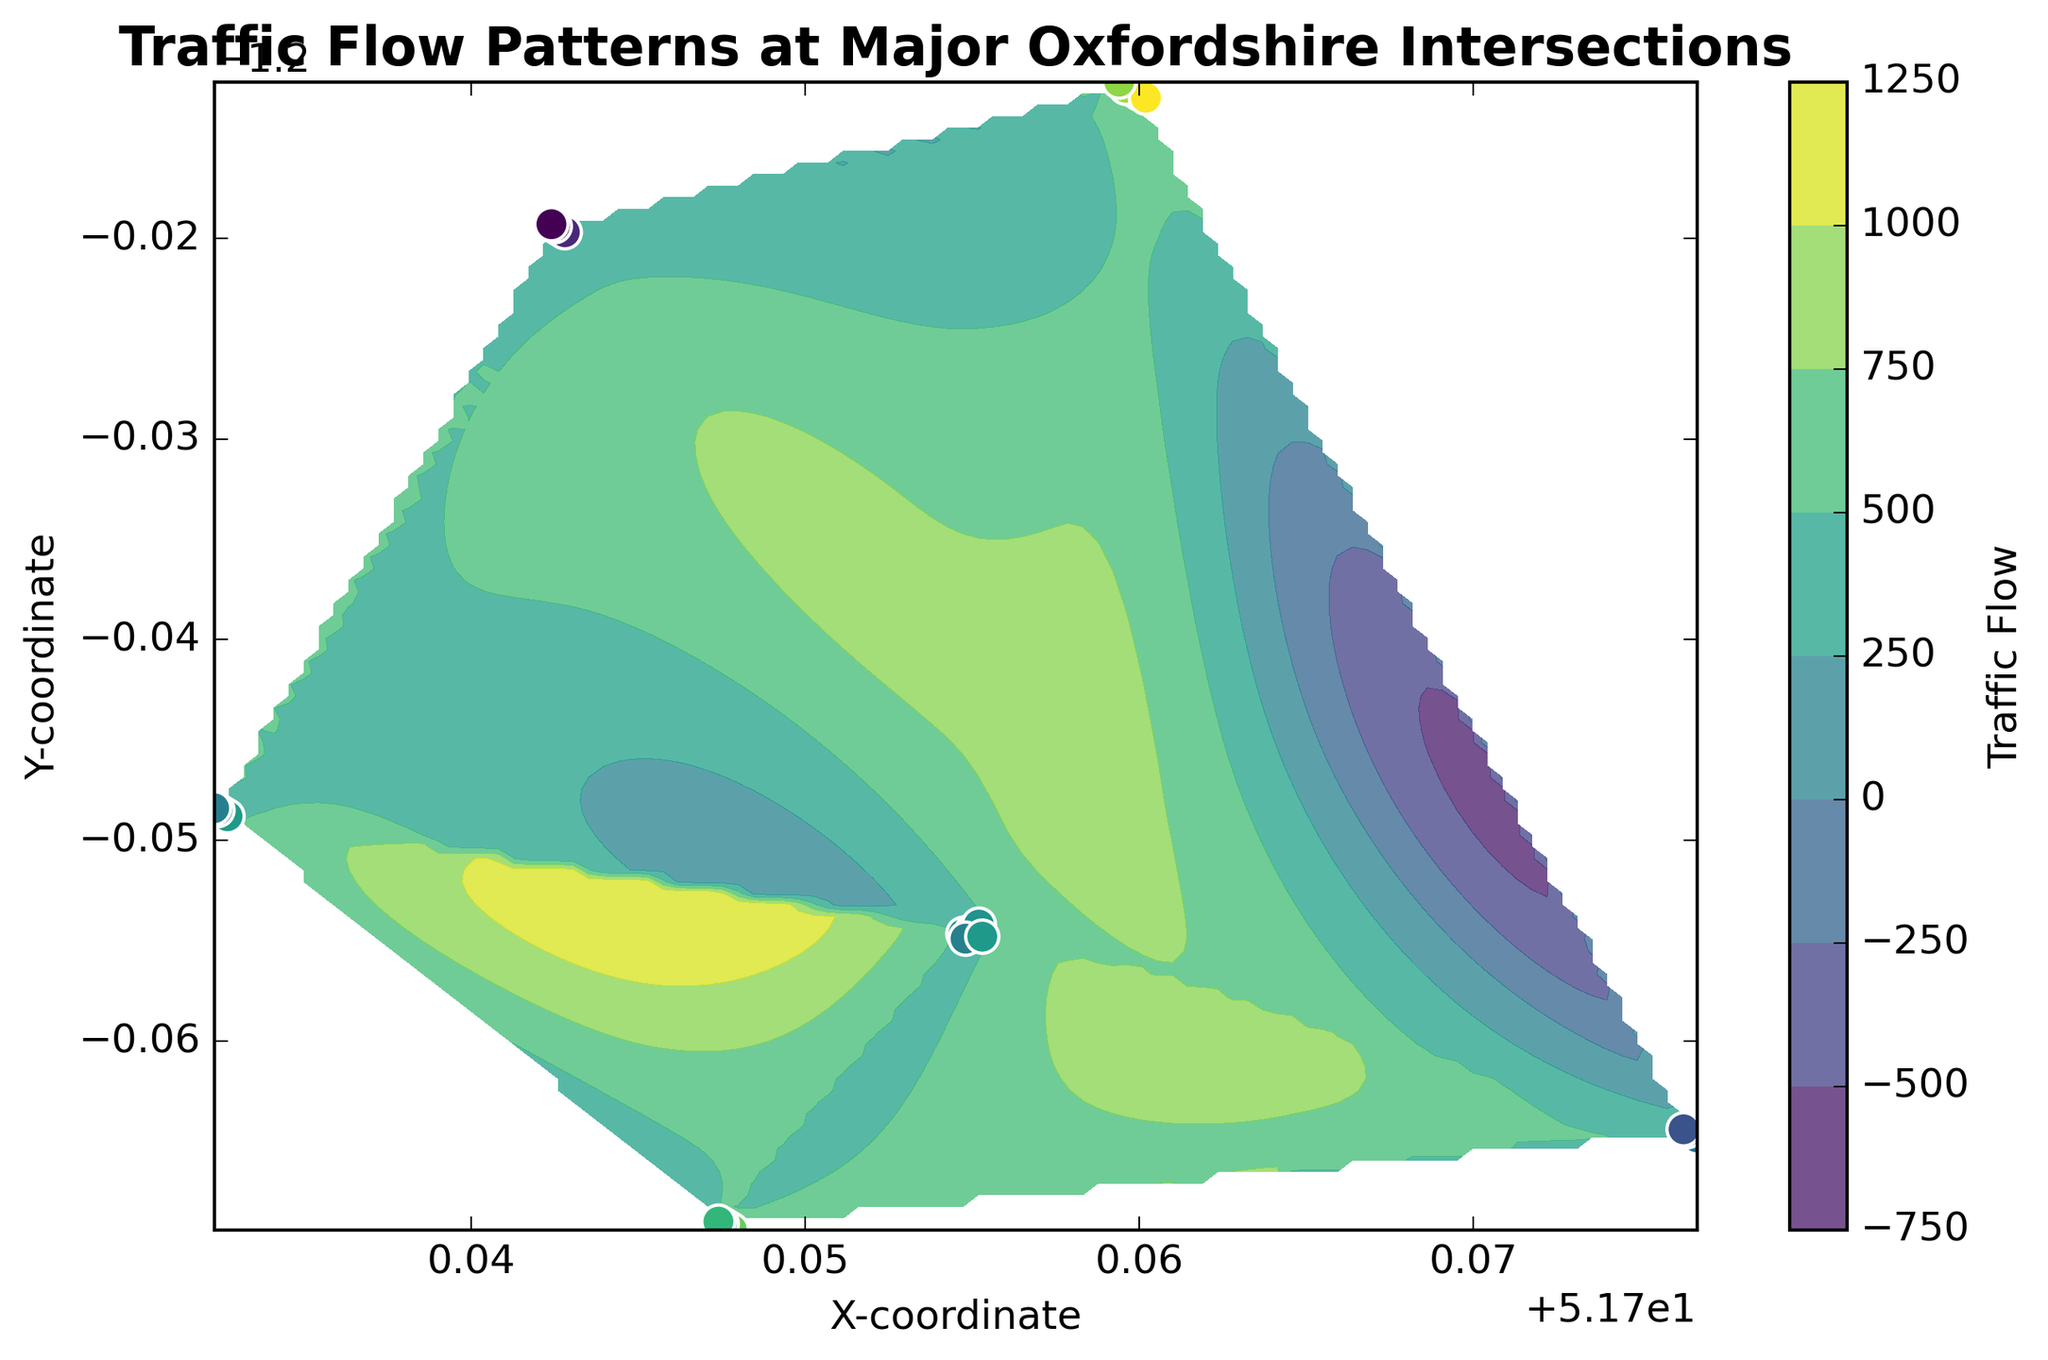Which intersection has the highest traffic flow? By looking at the color bar, yellow-green indicates the highest traffic flow. The Headington Roundabout area shows the brightest color, suggesting it's the highest.
Answer: Headington Roundabout What is the general range of traffic flow values around Central Oxford? From the color in the contour plot, Central Oxford is mostly in the range from green to light green-blue, implying a traffic flow range of approximately 420-470.
Answer: 420-470 Compare the traffic flow at Botley Interchange and Abingdon Road. Which one has higher traffic flow on average? Botley Interchange is represented by a brighter green, while Abingdon Road is in the mid-green range, indicating Botley Interchange has higher traffic flow.
Answer: Botley Interchange In which area do we observe the lowest traffic flow? The Cowley Road Light shows the darkest blue color, which means it has the lowest traffic flow.
Answer: Cowley Road Light Which intersections have traffic flow values greater than 500? Headington Roundabout and Botley Interchange show colors above 500 on the color bar, indicating those intersections have traffic flow values greater than 500.
Answer: Headington Roundabout, Botley Interchange What is the difference in traffic flow between the highest and lowest observed values? The highest value is around 630 (Headington Roundabout, yellow-green) and the lowest is around 280 (Cowley Road Light, dark blue), so the difference is 630 - 280 = 350.
Answer: 350 How does the traffic flow at Summertown Intersection visually compare to that of Cowley Road Light? Summertown Intersection shows colors in the mid-green range (370-410), while Cowley Road Light is in dark blue (280-320), indicating Summertown has higher traffic flow.
Answer: Summertown Intersection has higher traffic flow What's the average traffic flow in Botley Interchange based on the graphical color representation? Botley Interchange mostly shows light green colors indicating traffic flow values range from 510 to 550. The average can be approximated as (510 + 520 + 530 + 540 + 550)/5 = 530.
Answer: 530 Is there a noticeable clustering of any traffic flow values at specific coordinates? Yes, a noticeable clustering of higher traffic flow values around the Headington Roundabout area is apparent due to the concentrated bright yellow-green color.
Answer: Yes, at the Headington Roundabout What is the difference between the highest traffic flow in Central Oxford and Cowley Road Light? The highest traffic flow in Central Oxford is around 470, and the highest in Cowley Road Light is around 320. The difference is 470 - 320 = 150.
Answer: 150 